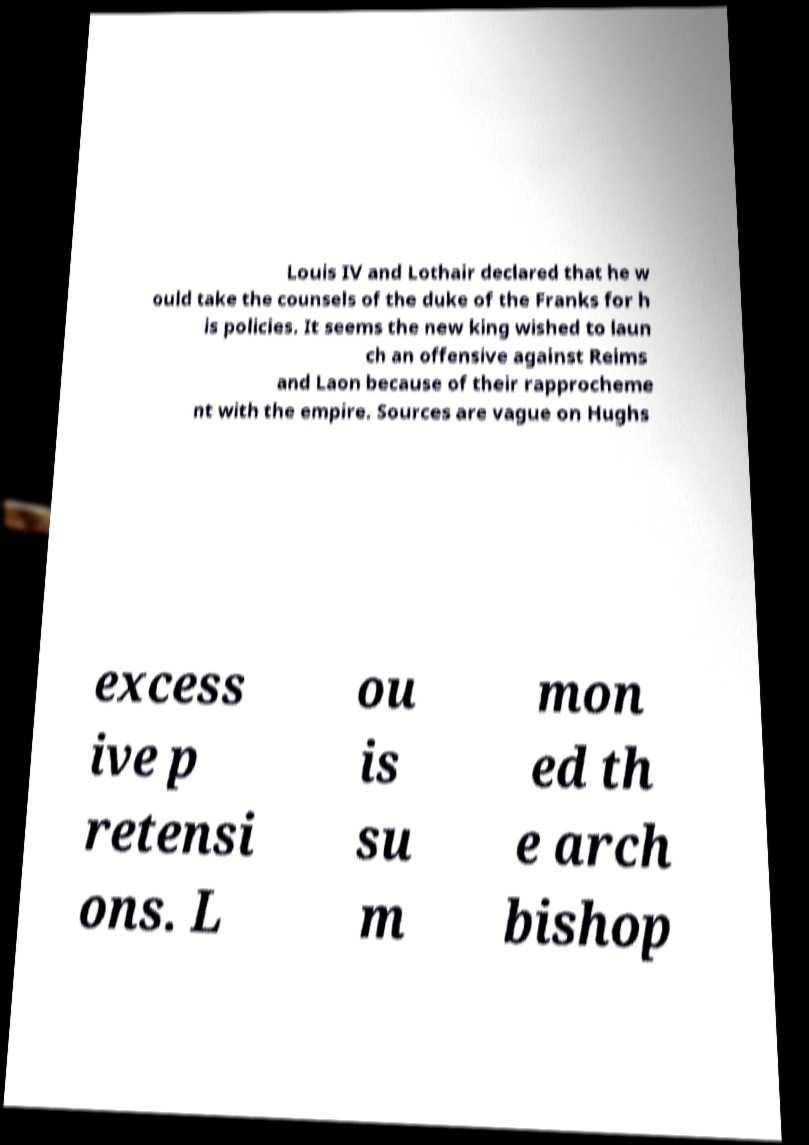There's text embedded in this image that I need extracted. Can you transcribe it verbatim? Louis IV and Lothair declared that he w ould take the counsels of the duke of the Franks for h is policies. It seems the new king wished to laun ch an offensive against Reims and Laon because of their rapprocheme nt with the empire. Sources are vague on Hughs excess ive p retensi ons. L ou is su m mon ed th e arch bishop 